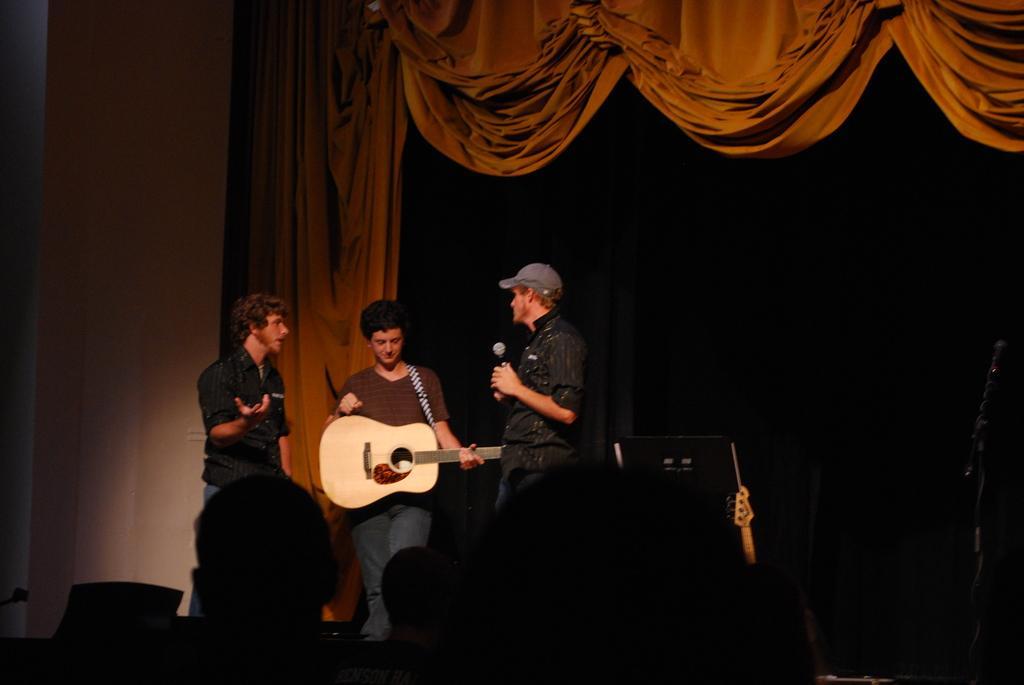Could you give a brief overview of what you see in this image? As we can see in the image there is a wall, curtain and three people standing on stage. The man who is standing here is holding guitar in his hands. 